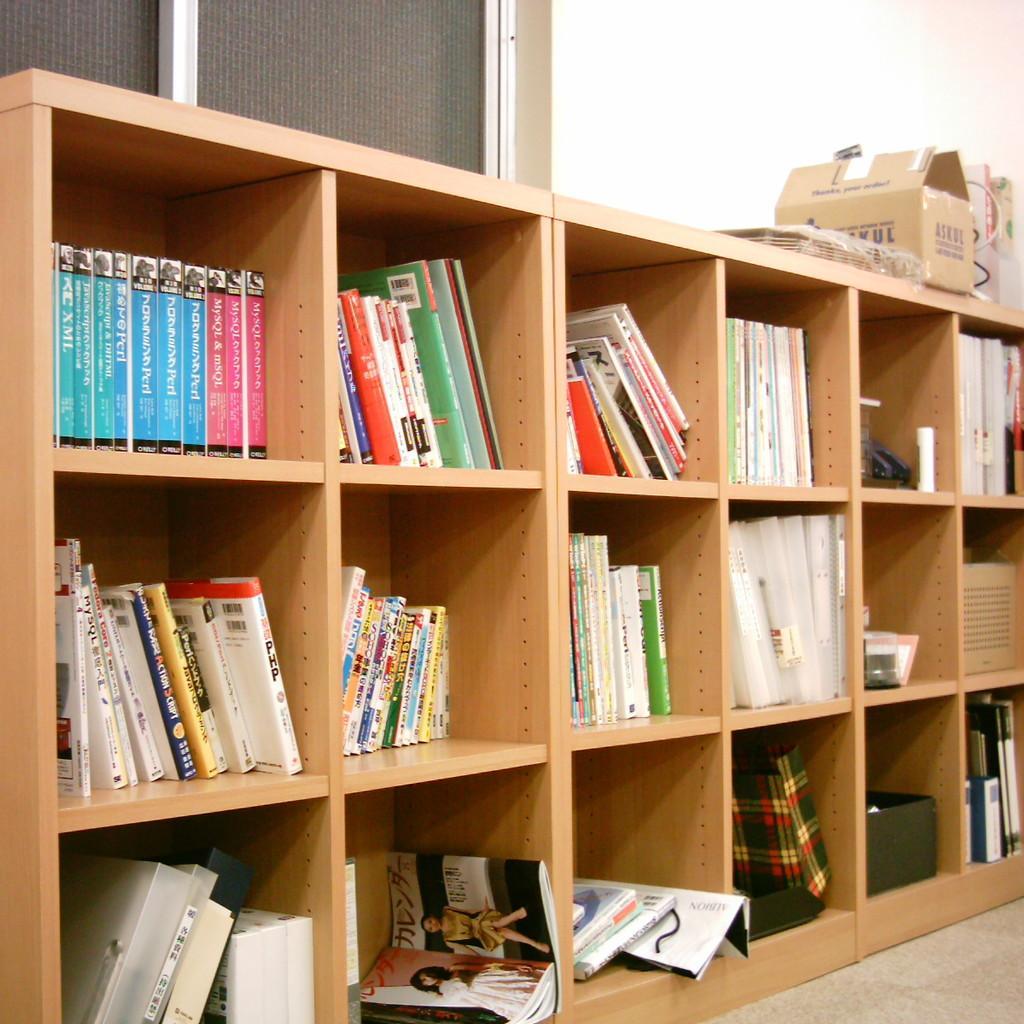How would you summarize this image in a sentence or two? In this picture we can see a rack, there are some books on the rack, we can see a cardboard box here, in the background there is a wall, we can see a window here. 